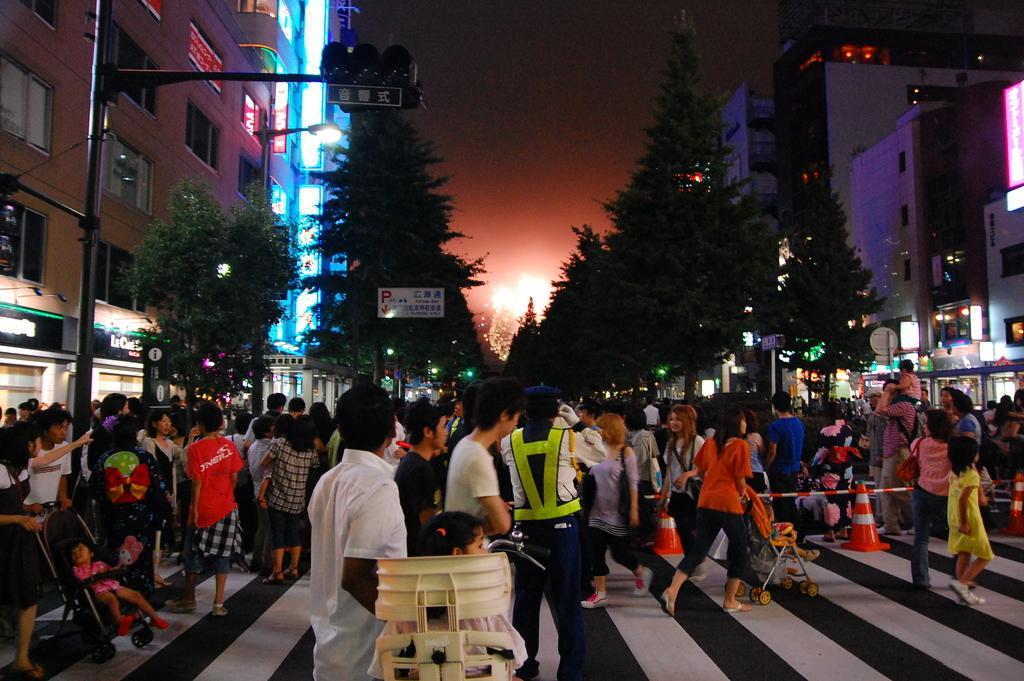Can you describe this image briefly? In this picture we can see a few people, babies sitting in the strollers, a few signs and some text on the boards. These boards are visible on the poles. We can see a few trees, buildings and other objects and the sky. 